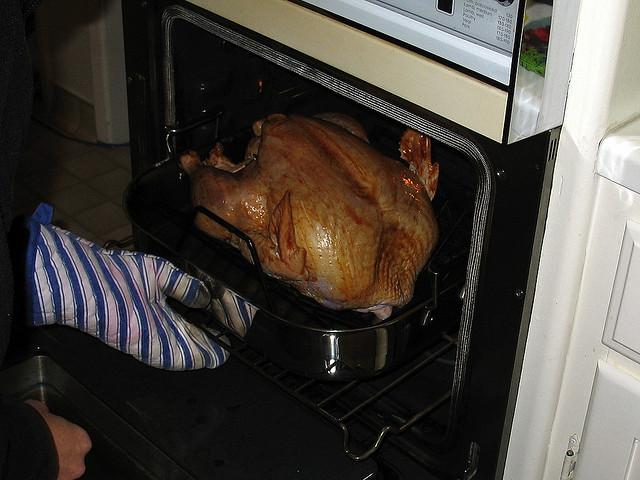Which bird could be a turkey?
Quick response, please. In oven. What type of food is shown in the oven?
Short answer required. Turkey. Is that duck?
Write a very short answer. No. Is the oven on?
Answer briefly. Yes. What colors make up the oven mitten?
Keep it brief. Blue and white. Is that a cat or a baked ham?
Answer briefly. Neither. Is the animal inside the oven alive?
Quick response, please. No. How many human hands are in the scene?
Give a very brief answer. 1. 